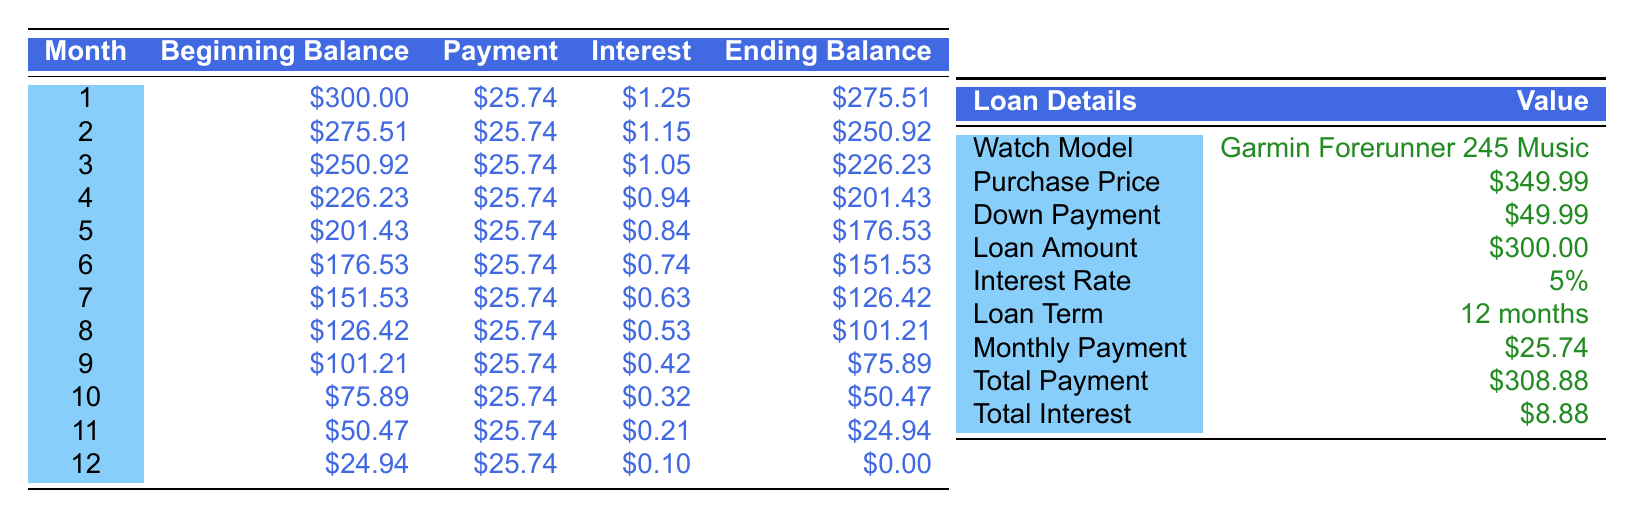What is the purchase price of the Garmin Forerunner 245 Music? The purchase price is explicitly listed in the loan details section of the table under "Purchase Price." It states that the price is 349.99.
Answer: 349.99 What is the total payment for the loan? The total payment is specified under the loan details section of the table. It is 308.88.
Answer: 308.88 How much interest will be paid over the duration of the loan? The total interest paid is indicated in the loan details, showing that the total interest is 8.88.
Answer: 8.88 Is the monthly payment more than the monthly savings target? To determine this, compare the monthly payment (25.74) and the monthly savings target (30.00). Since 25.74 < 30.00, the monthly payment is not more than the savings target.
Answer: No How much do I need to save monthly to reach my total savings goal? The total savings goal is 360.00, and the current savings is 100.00. We need to save a total of 260.00 over 9 months, which gives a required savings of 260.00 / 9 ≈ 28.89 per month. Since the target is already set at 30.00, the plan is on track.
Answer: 30.00 What is the ending balance after the 6th month? Referring to the monthly amortization table, the ending balance at the 6th month is listed as 151.53 in the corresponding row.
Answer: 151.53 What was the beginning balance in the 3rd month? This information can be found in the amortization table; the beginning balance in the 3rd month is clearly stated as 250.92.
Answer: 250.92 How much is left to pay after the 9th month? The ending balance after the 9th month, found in the amortization table, is 75.89. This is the amount left to pay.
Answer: 75.89 What is the average monthly interest paid over the term of the loan? To find the average monthly interest, add the total interest paid (8.88) and divide it by the loan term (12 months): 8.88 / 12 = 0.74. This gives the average monthly interest payment.
Answer: 0.74 How many months are left until I reach my savings goal? The time to goal in months is specified as 9 months within the savings plan details, so that's the number of months left to reach the savings goal.
Answer: 9 